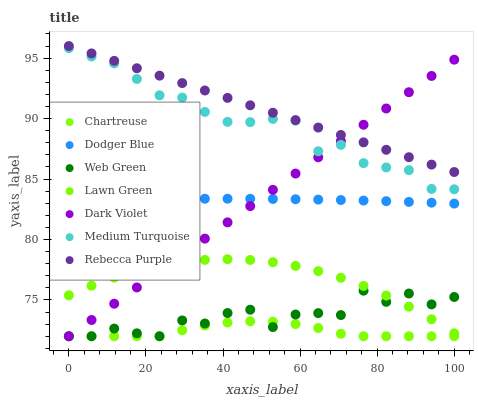Does Chartreuse have the minimum area under the curve?
Answer yes or no. Yes. Does Rebecca Purple have the maximum area under the curve?
Answer yes or no. Yes. Does Dark Violet have the minimum area under the curve?
Answer yes or no. No. Does Dark Violet have the maximum area under the curve?
Answer yes or no. No. Is Dark Violet the smoothest?
Answer yes or no. Yes. Is Web Green the roughest?
Answer yes or no. Yes. Is Chartreuse the smoothest?
Answer yes or no. No. Is Chartreuse the roughest?
Answer yes or no. No. Does Dark Violet have the lowest value?
Answer yes or no. Yes. Does Dodger Blue have the lowest value?
Answer yes or no. No. Does Rebecca Purple have the highest value?
Answer yes or no. Yes. Does Dark Violet have the highest value?
Answer yes or no. No. Is Web Green less than Rebecca Purple?
Answer yes or no. Yes. Is Dodger Blue greater than Lawn Green?
Answer yes or no. Yes. Does Dodger Blue intersect Dark Violet?
Answer yes or no. Yes. Is Dodger Blue less than Dark Violet?
Answer yes or no. No. Is Dodger Blue greater than Dark Violet?
Answer yes or no. No. Does Web Green intersect Rebecca Purple?
Answer yes or no. No. 